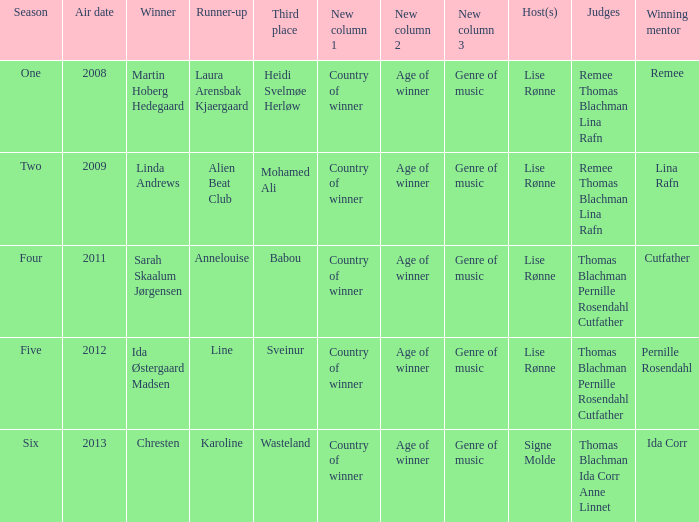Which season did Ida Corr win? Six. 